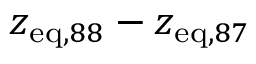Convert formula to latex. <formula><loc_0><loc_0><loc_500><loc_500>z _ { e q , 8 8 } - z _ { e q , 8 7 }</formula> 